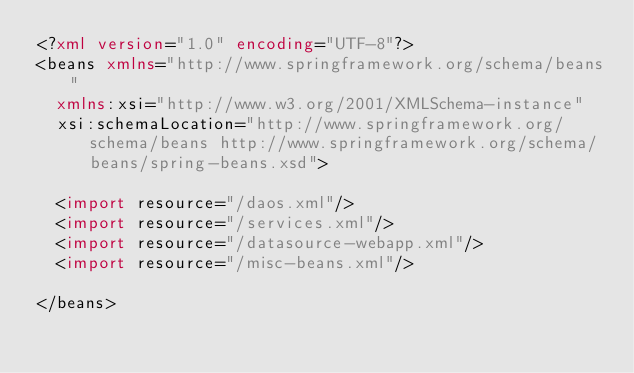Convert code to text. <code><loc_0><loc_0><loc_500><loc_500><_XML_><?xml version="1.0" encoding="UTF-8"?>
<beans xmlns="http://www.springframework.org/schema/beans"
	xmlns:xsi="http://www.w3.org/2001/XMLSchema-instance"
	xsi:schemaLocation="http://www.springframework.org/schema/beans http://www.springframework.org/schema/beans/spring-beans.xsd">

	<import resource="/daos.xml"/>
	<import resource="/services.xml"/>
	<import resource="/datasource-webapp.xml"/>
	<import resource="/misc-beans.xml"/>	

</beans>
</code> 